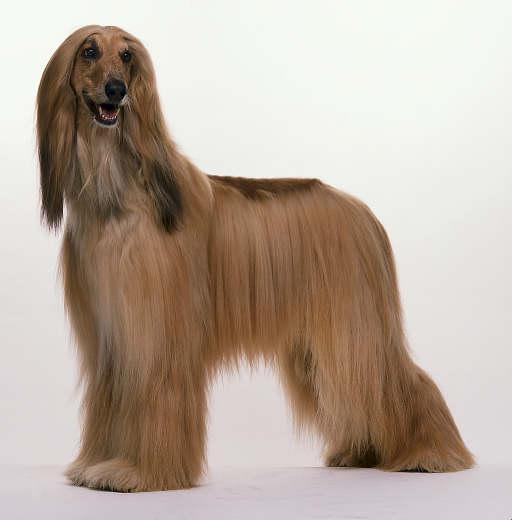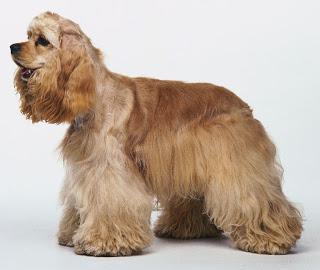The first image is the image on the left, the second image is the image on the right. For the images shown, is this caption "Each image contains one afghan hound with light-orangish hair who is gazing to the left, and one of the depicted dogs is standing on all fours." true? Answer yes or no. No. The first image is the image on the left, the second image is the image on the right. For the images shown, is this caption "Both dogs' mouths are open." true? Answer yes or no. Yes. 